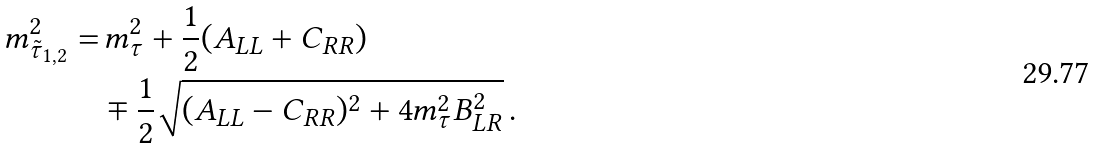<formula> <loc_0><loc_0><loc_500><loc_500>m _ { \tilde { \tau } _ { 1 , 2 } } ^ { 2 } = & \, m _ { \tau } ^ { 2 } + \frac { 1 } { 2 } ( A _ { L L } + C _ { R R } ) \\ & \mp \frac { 1 } { 2 } \sqrt { ( A _ { L L } - C _ { R R } ) ^ { 2 } + 4 m _ { \tau } ^ { 2 } B _ { L R } ^ { 2 } } \, .</formula> 